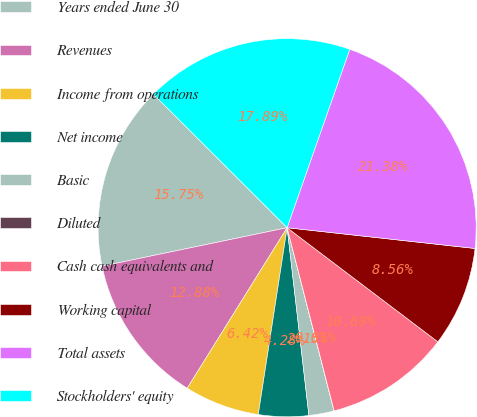Convert chart to OTSL. <chart><loc_0><loc_0><loc_500><loc_500><pie_chart><fcel>Years ended June 30<fcel>Revenues<fcel>Income from operations<fcel>Net income<fcel>Basic<fcel>Diluted<fcel>Cash cash equivalents and<fcel>Working capital<fcel>Total assets<fcel>Stockholders' equity<nl><fcel>15.75%<fcel>12.88%<fcel>6.42%<fcel>4.28%<fcel>2.15%<fcel>0.01%<fcel>10.69%<fcel>8.56%<fcel>21.38%<fcel>17.89%<nl></chart> 